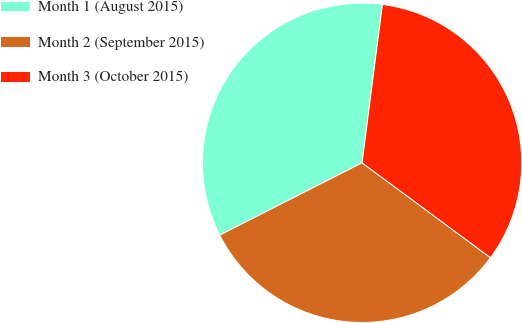Convert chart. <chart><loc_0><loc_0><loc_500><loc_500><pie_chart><fcel>Month 1 (August 2015)<fcel>Month 2 (September 2015)<fcel>Month 3 (October 2015)<nl><fcel>34.52%<fcel>32.39%<fcel>33.09%<nl></chart> 